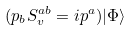Convert formula to latex. <formula><loc_0><loc_0><loc_500><loc_500>( p _ { b } S _ { v } ^ { a b } = i p ^ { a } ) | \Phi \rangle</formula> 